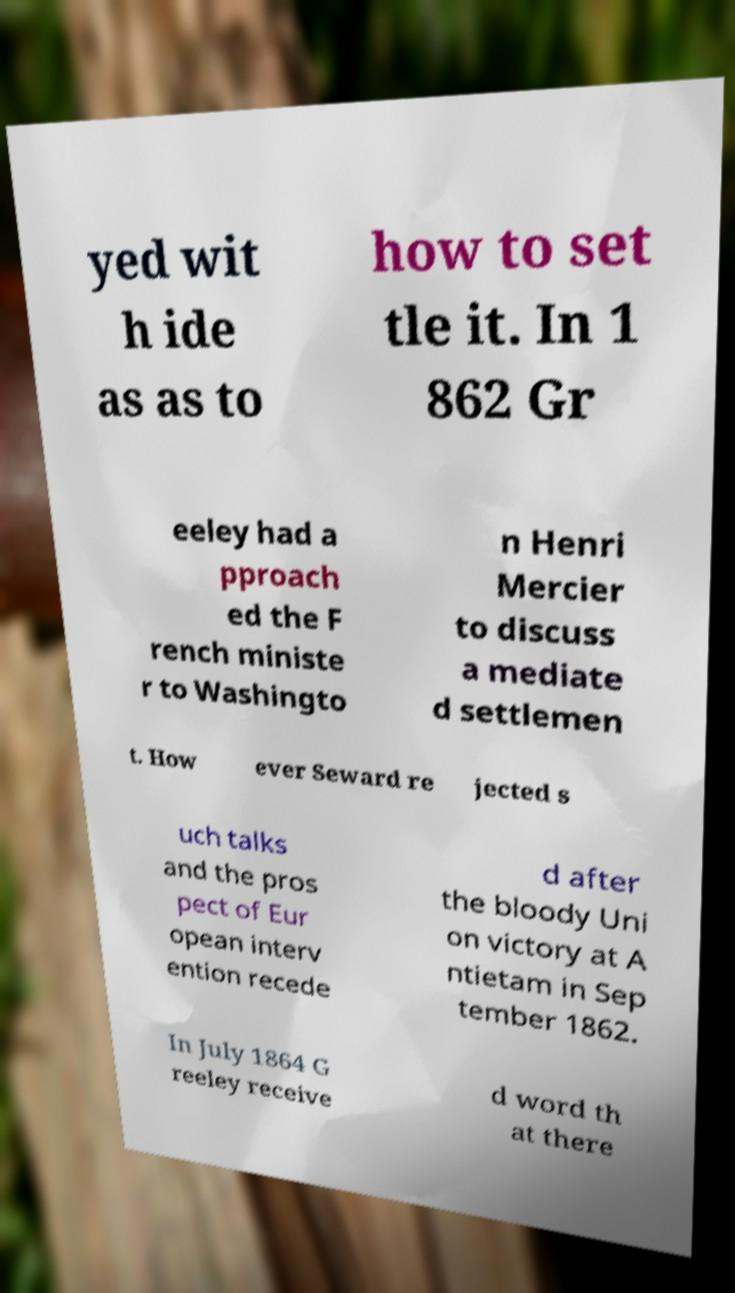I need the written content from this picture converted into text. Can you do that? yed wit h ide as as to how to set tle it. In 1 862 Gr eeley had a pproach ed the F rench ministe r to Washingto n Henri Mercier to discuss a mediate d settlemen t. How ever Seward re jected s uch talks and the pros pect of Eur opean interv ention recede d after the bloody Uni on victory at A ntietam in Sep tember 1862. In July 1864 G reeley receive d word th at there 